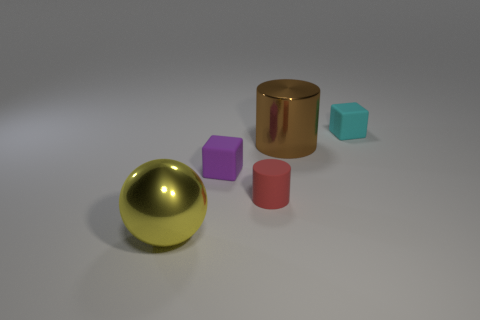Subtract all cyan cylinders. Subtract all brown blocks. How many cylinders are left? 2 Add 5 big green shiny spheres. How many objects exist? 10 Subtract all blocks. How many objects are left? 3 Add 1 big objects. How many big objects exist? 3 Subtract 0 red cubes. How many objects are left? 5 Subtract all brown things. Subtract all red cylinders. How many objects are left? 3 Add 5 big yellow balls. How many big yellow balls are left? 6 